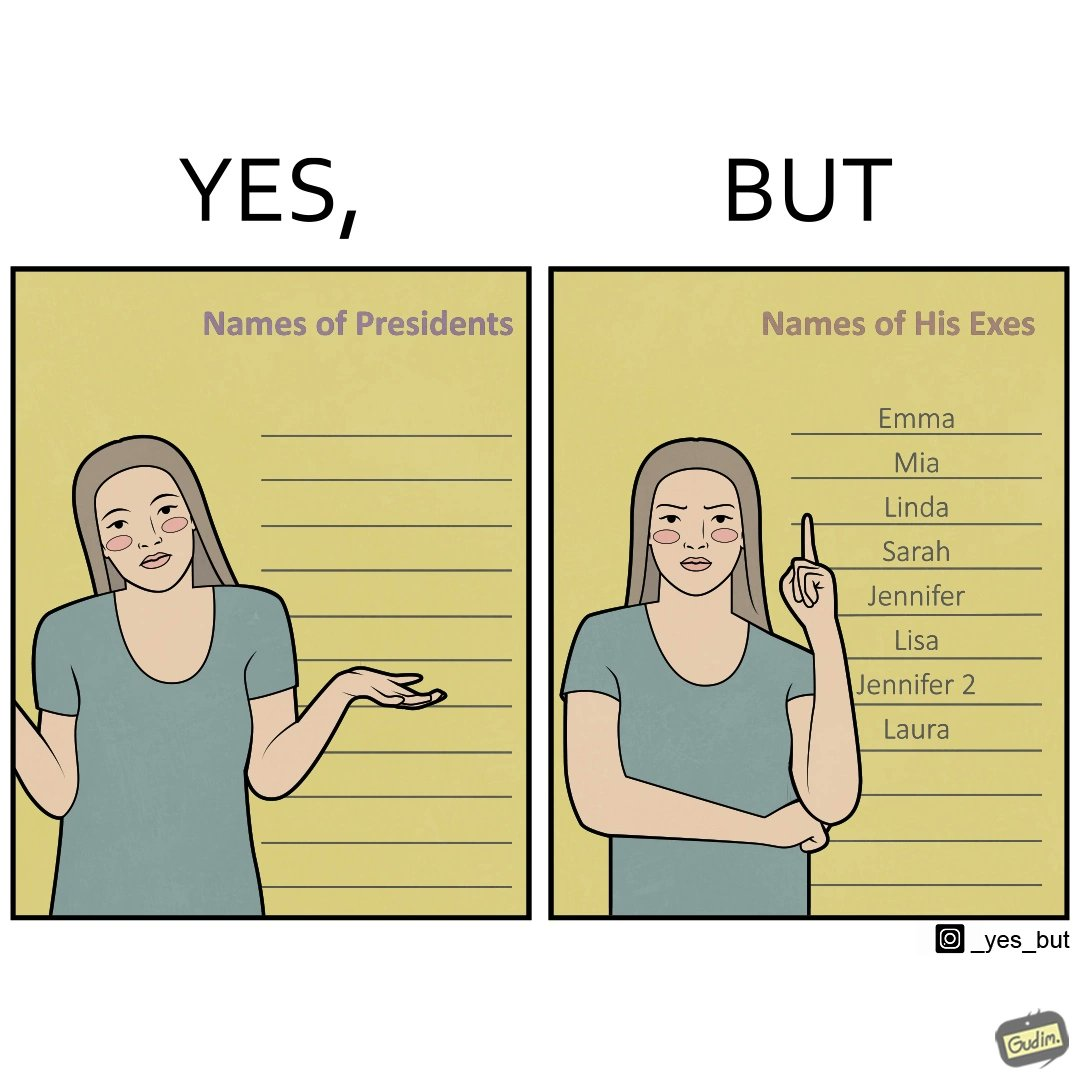Describe the contrast between the left and right parts of this image. In the left part of the image: It is a woman who does not know the names of presidents In the right part of the image: It is a woman who has written down a list of "his"
Exes 